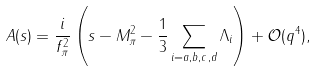Convert formula to latex. <formula><loc_0><loc_0><loc_500><loc_500>A ( s ) = \frac { i } { f _ { \pi } ^ { 2 } } \left ( s - M _ { \pi } ^ { 2 } - \frac { 1 } { 3 } \sum _ { i = a , b , c , d } \Lambda _ { i } \right ) + \mathcal { O } ( q ^ { 4 } ) ,</formula> 